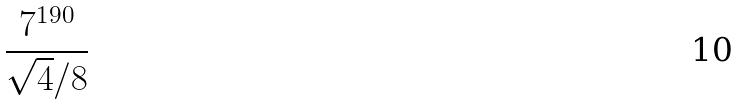<formula> <loc_0><loc_0><loc_500><loc_500>\frac { 7 ^ { 1 9 0 } } { \sqrt { 4 } / 8 }</formula> 